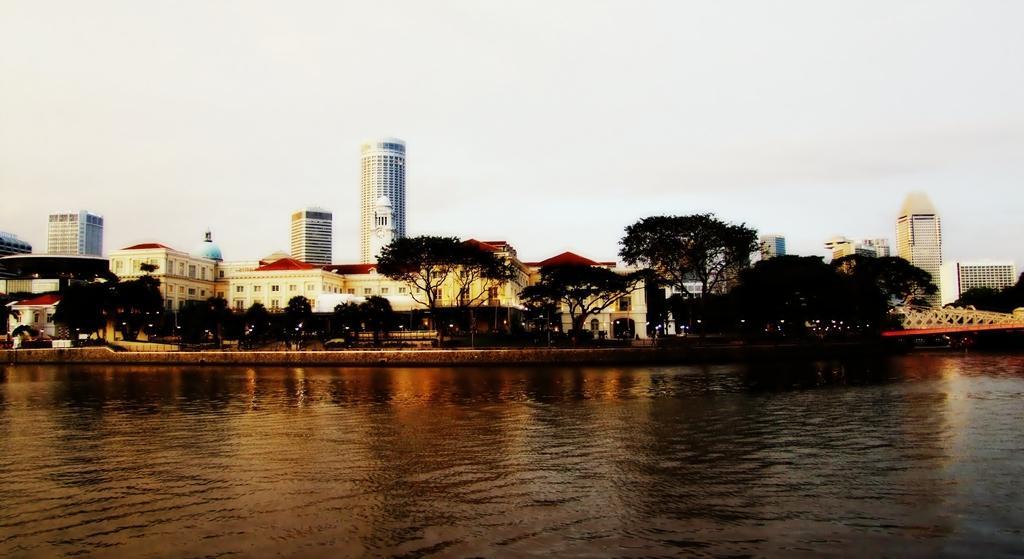Could you give a brief overview of what you see in this image? In the picture I can see water and there are few trees and buildings in the background. 